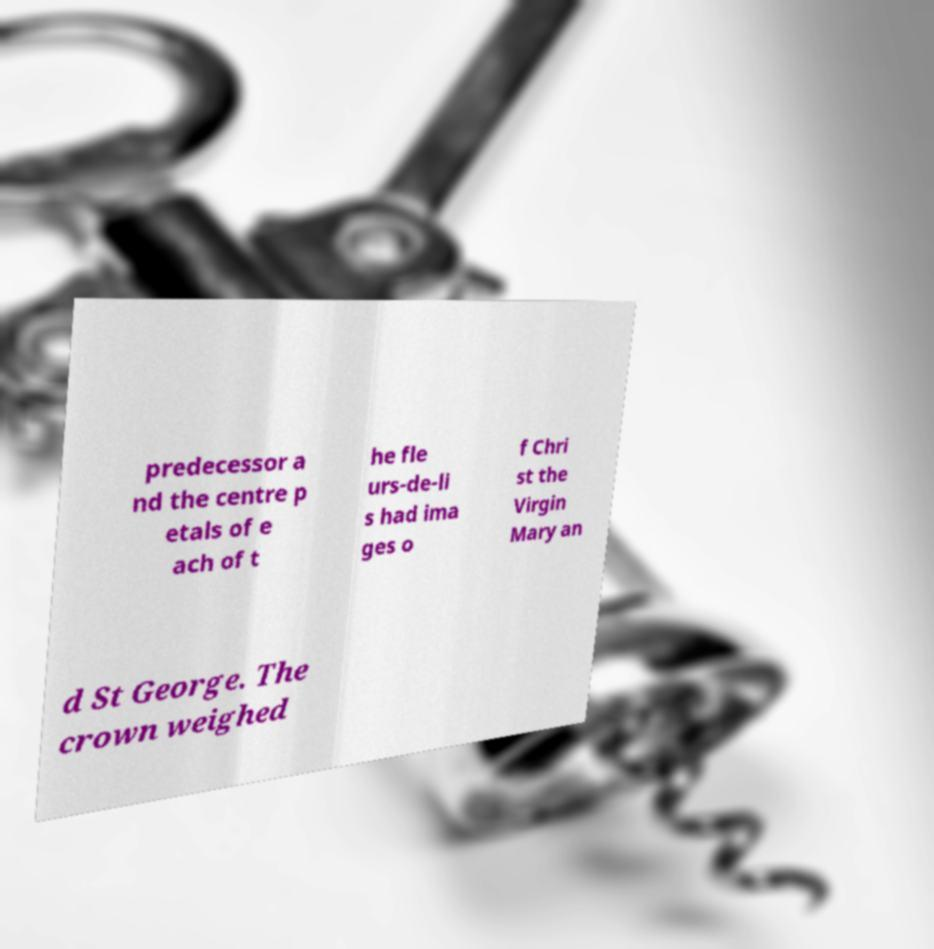Could you assist in decoding the text presented in this image and type it out clearly? predecessor a nd the centre p etals of e ach of t he fle urs-de-li s had ima ges o f Chri st the Virgin Mary an d St George. The crown weighed 